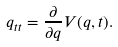<formula> <loc_0><loc_0><loc_500><loc_500>q _ { t t } = \frac { \partial } { \partial q } V ( q , t ) .</formula> 